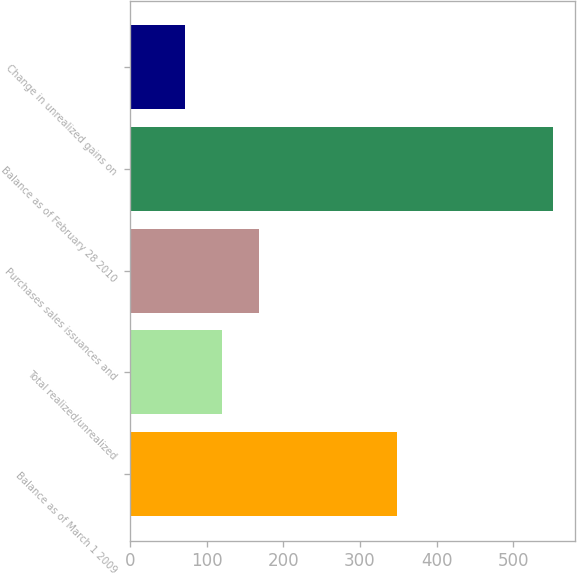<chart> <loc_0><loc_0><loc_500><loc_500><bar_chart><fcel>Balance as of March 1 2009<fcel>Total realized/unrealized<fcel>Purchases sales issuances and<fcel>Balance as of February 28 2010<fcel>Change in unrealized gains on<nl><fcel>348.3<fcel>119.95<fcel>168<fcel>552.4<fcel>71.9<nl></chart> 